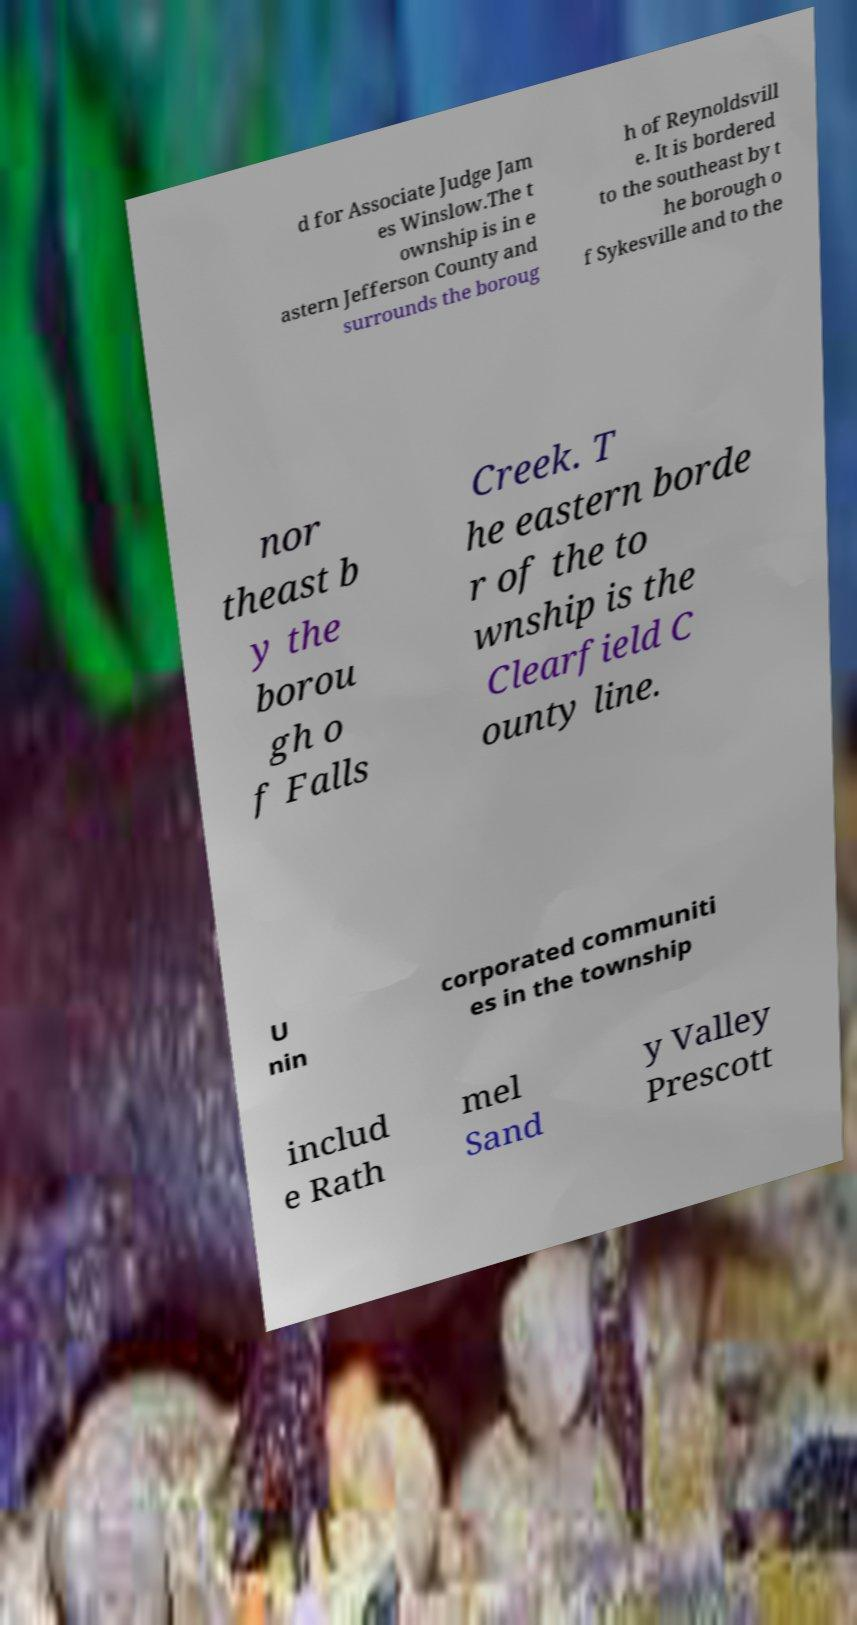Can you read and provide the text displayed in the image?This photo seems to have some interesting text. Can you extract and type it out for me? d for Associate Judge Jam es Winslow.The t ownship is in e astern Jefferson County and surrounds the boroug h of Reynoldsvill e. It is bordered to the southeast by t he borough o f Sykesville and to the nor theast b y the borou gh o f Falls Creek. T he eastern borde r of the to wnship is the Clearfield C ounty line. U nin corporated communiti es in the township includ e Rath mel Sand y Valley Prescott 